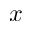Convert formula to latex. <formula><loc_0><loc_0><loc_500><loc_500>x</formula> 